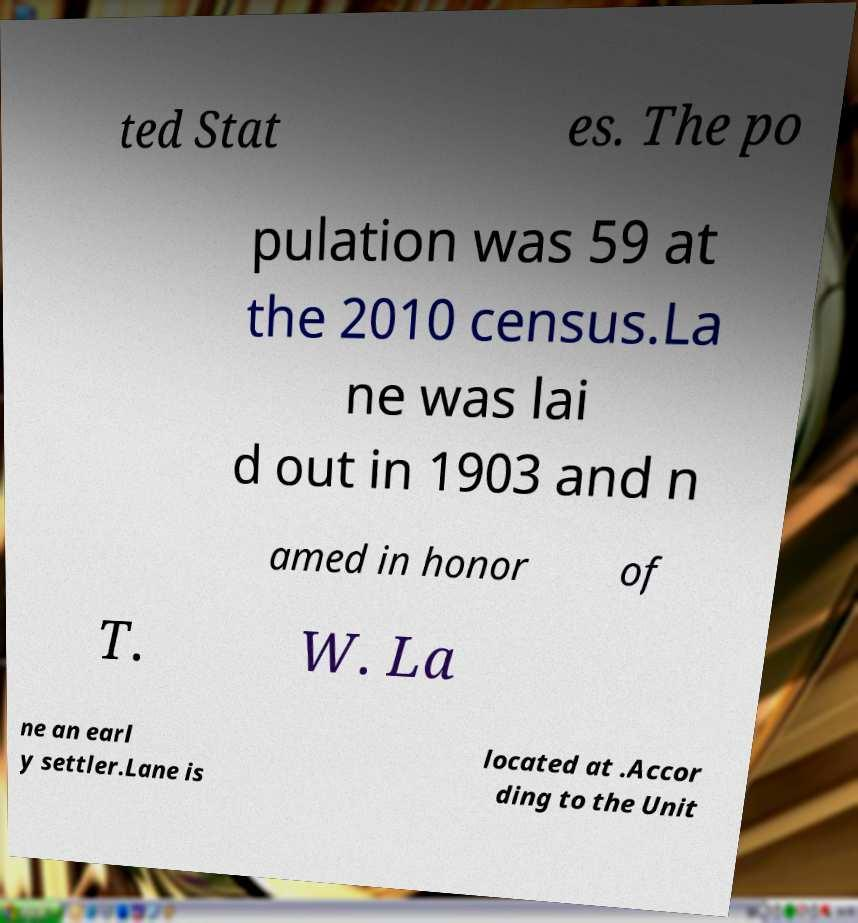Could you assist in decoding the text presented in this image and type it out clearly? ted Stat es. The po pulation was 59 at the 2010 census.La ne was lai d out in 1903 and n amed in honor of T. W. La ne an earl y settler.Lane is located at .Accor ding to the Unit 